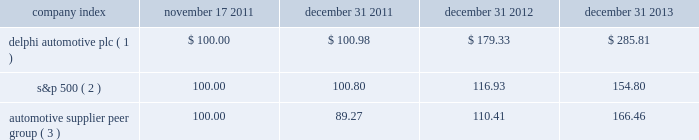Stock performance graph * $ 100 invested on 11/17/11 in our stock or 10/31/11 in the relevant index , including reinvestment of dividends .
Fiscal year ending december 31 , 2013 .
( 1 ) delphi automotive plc ( 2 ) s&p 500 2013 standard & poor 2019s 500 total return index ( 3 ) automotive supplier peer group 2013 russell 3000 auto parts index , including american axle & manufacturing , borgwarner inc. , cooper tire & rubber company , dana holding corp. , delphi automotive plc , dorman products inc. , federal-mogul corp. , ford motor co. , fuel systems solutions inc. , general motors co. , gentex corp. , gentherm inc. , genuine parts co. , johnson controls inc. , lkq corp. , lear corp. , meritor inc. , remy international inc. , standard motor products inc. , stoneridge inc. , superior industries international , trw automotive holdings corp. , tenneco inc. , tesla motors inc. , the goodyear tire & rubber co. , tower international inc. , visteon corp. , and wabco holdings inc .
Company index november 17 , december 31 , december 31 , december 31 .
Dividends on february 26 , 2013 , the board of directors approved the initiation of dividend payments on the company's ordinary shares .
The board of directors declared a regular quarterly cash dividend of $ 0.17 per ordinary share that was paid in each quarter of 2013 .
In addition , in january 2014 , the board of directors declared a regular quarterly cash dividend of $ 0.25 per ordinary share , payable on february 27 , 2014 to shareholders of record at the close of business on february 18 , 2014 .
In october 2011 , the board of managers of delphi automotive llp approved a distribution of approximately $ 95 million , which was paid on december 5 , 2011 , principally in respect of taxes , to members of delphi automotive llp who held membership interests as of the close of business on october 31 , 2011. .
What is the increase in the dividend in total for the year of 2014? 
Computations: ((0.25 - 0.17) * 4)
Answer: 0.32. 